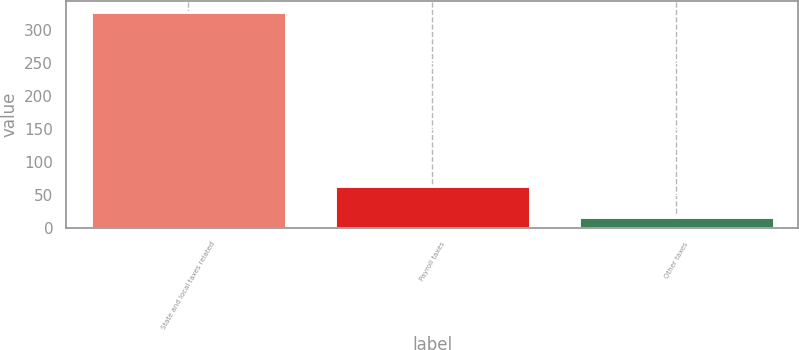Convert chart. <chart><loc_0><loc_0><loc_500><loc_500><bar_chart><fcel>State and local taxes related<fcel>Payroll taxes<fcel>Other taxes<nl><fcel>328<fcel>63<fcel>17<nl></chart> 